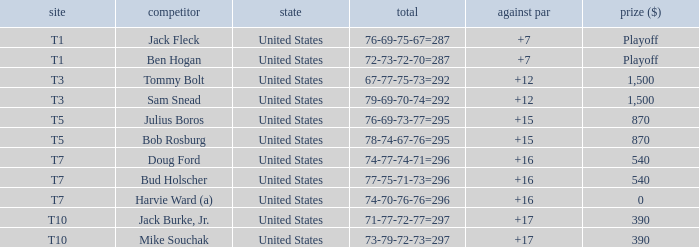What is the total of all to par with player Bob Rosburg? 15.0. 